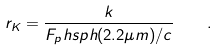<formula> <loc_0><loc_0><loc_500><loc_500>r _ { K } = \frac { k } { F _ { p } h s p h ( 2 . 2 \mu m ) / c } \quad .</formula> 